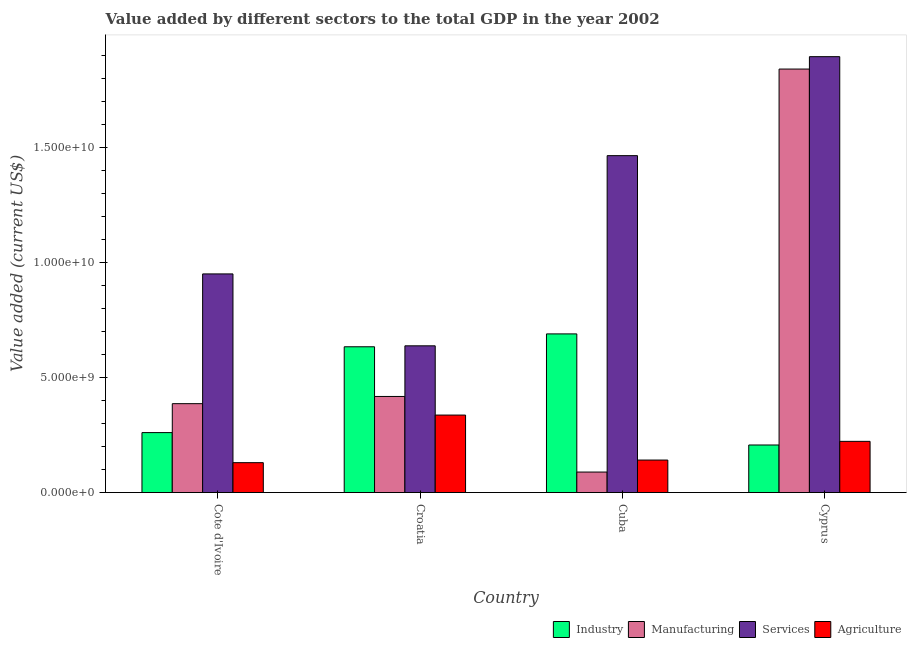Are the number of bars per tick equal to the number of legend labels?
Give a very brief answer. Yes. Are the number of bars on each tick of the X-axis equal?
Your answer should be very brief. Yes. How many bars are there on the 3rd tick from the left?
Ensure brevity in your answer.  4. What is the label of the 4th group of bars from the left?
Ensure brevity in your answer.  Cyprus. What is the value added by manufacturing sector in Cuba?
Your answer should be very brief. 8.92e+08. Across all countries, what is the maximum value added by industrial sector?
Your answer should be compact. 6.89e+09. Across all countries, what is the minimum value added by manufacturing sector?
Provide a short and direct response. 8.92e+08. In which country was the value added by agricultural sector maximum?
Your answer should be compact. Croatia. In which country was the value added by industrial sector minimum?
Make the answer very short. Cyprus. What is the total value added by agricultural sector in the graph?
Offer a very short reply. 8.31e+09. What is the difference between the value added by manufacturing sector in Cuba and that in Cyprus?
Provide a succinct answer. -1.75e+1. What is the difference between the value added by agricultural sector in Cuba and the value added by services sector in Cote d'Ivoire?
Make the answer very short. -8.08e+09. What is the average value added by agricultural sector per country?
Provide a succinct answer. 2.08e+09. What is the difference between the value added by manufacturing sector and value added by agricultural sector in Cote d'Ivoire?
Your answer should be very brief. 2.56e+09. What is the ratio of the value added by industrial sector in Croatia to that in Cyprus?
Your answer should be very brief. 3.06. Is the value added by manufacturing sector in Cuba less than that in Cyprus?
Provide a short and direct response. Yes. Is the difference between the value added by industrial sector in Cuba and Cyprus greater than the difference between the value added by services sector in Cuba and Cyprus?
Keep it short and to the point. Yes. What is the difference between the highest and the second highest value added by services sector?
Provide a succinct answer. 4.30e+09. What is the difference between the highest and the lowest value added by industrial sector?
Your answer should be compact. 4.83e+09. In how many countries, is the value added by services sector greater than the average value added by services sector taken over all countries?
Offer a very short reply. 2. Is it the case that in every country, the sum of the value added by industrial sector and value added by manufacturing sector is greater than the sum of value added by services sector and value added by agricultural sector?
Ensure brevity in your answer.  No. What does the 3rd bar from the left in Croatia represents?
Keep it short and to the point. Services. What does the 1st bar from the right in Cuba represents?
Your answer should be very brief. Agriculture. Is it the case that in every country, the sum of the value added by industrial sector and value added by manufacturing sector is greater than the value added by services sector?
Make the answer very short. No. Are all the bars in the graph horizontal?
Provide a succinct answer. No. What is the difference between two consecutive major ticks on the Y-axis?
Offer a very short reply. 5.00e+09. Does the graph contain grids?
Give a very brief answer. No. What is the title of the graph?
Your answer should be very brief. Value added by different sectors to the total GDP in the year 2002. What is the label or title of the Y-axis?
Your answer should be very brief. Value added (current US$). What is the Value added (current US$) of Industry in Cote d'Ivoire?
Offer a terse response. 2.61e+09. What is the Value added (current US$) in Manufacturing in Cote d'Ivoire?
Offer a terse response. 3.86e+09. What is the Value added (current US$) of Services in Cote d'Ivoire?
Keep it short and to the point. 9.50e+09. What is the Value added (current US$) in Agriculture in Cote d'Ivoire?
Make the answer very short. 1.30e+09. What is the Value added (current US$) in Industry in Croatia?
Keep it short and to the point. 6.33e+09. What is the Value added (current US$) of Manufacturing in Croatia?
Your response must be concise. 4.18e+09. What is the Value added (current US$) of Services in Croatia?
Keep it short and to the point. 6.37e+09. What is the Value added (current US$) of Agriculture in Croatia?
Offer a terse response. 3.37e+09. What is the Value added (current US$) of Industry in Cuba?
Make the answer very short. 6.89e+09. What is the Value added (current US$) in Manufacturing in Cuba?
Your response must be concise. 8.92e+08. What is the Value added (current US$) in Services in Cuba?
Your answer should be very brief. 1.46e+1. What is the Value added (current US$) of Agriculture in Cuba?
Provide a succinct answer. 1.41e+09. What is the Value added (current US$) of Industry in Cyprus?
Keep it short and to the point. 2.07e+09. What is the Value added (current US$) of Manufacturing in Cyprus?
Your answer should be very brief. 1.84e+1. What is the Value added (current US$) in Services in Cyprus?
Provide a succinct answer. 1.89e+1. What is the Value added (current US$) of Agriculture in Cyprus?
Offer a very short reply. 2.23e+09. Across all countries, what is the maximum Value added (current US$) of Industry?
Offer a very short reply. 6.89e+09. Across all countries, what is the maximum Value added (current US$) of Manufacturing?
Your answer should be very brief. 1.84e+1. Across all countries, what is the maximum Value added (current US$) of Services?
Make the answer very short. 1.89e+1. Across all countries, what is the maximum Value added (current US$) in Agriculture?
Give a very brief answer. 3.37e+09. Across all countries, what is the minimum Value added (current US$) of Industry?
Offer a terse response. 2.07e+09. Across all countries, what is the minimum Value added (current US$) in Manufacturing?
Make the answer very short. 8.92e+08. Across all countries, what is the minimum Value added (current US$) of Services?
Your answer should be compact. 6.37e+09. Across all countries, what is the minimum Value added (current US$) in Agriculture?
Provide a short and direct response. 1.30e+09. What is the total Value added (current US$) in Industry in the graph?
Your answer should be very brief. 1.79e+1. What is the total Value added (current US$) in Manufacturing in the graph?
Keep it short and to the point. 2.73e+1. What is the total Value added (current US$) of Services in the graph?
Offer a very short reply. 4.94e+1. What is the total Value added (current US$) of Agriculture in the graph?
Offer a very short reply. 8.31e+09. What is the difference between the Value added (current US$) of Industry in Cote d'Ivoire and that in Croatia?
Provide a succinct answer. -3.73e+09. What is the difference between the Value added (current US$) of Manufacturing in Cote d'Ivoire and that in Croatia?
Your response must be concise. -3.13e+08. What is the difference between the Value added (current US$) in Services in Cote d'Ivoire and that in Croatia?
Keep it short and to the point. 3.12e+09. What is the difference between the Value added (current US$) in Agriculture in Cote d'Ivoire and that in Croatia?
Provide a short and direct response. -2.07e+09. What is the difference between the Value added (current US$) of Industry in Cote d'Ivoire and that in Cuba?
Ensure brevity in your answer.  -4.29e+09. What is the difference between the Value added (current US$) in Manufacturing in Cote d'Ivoire and that in Cuba?
Your answer should be compact. 2.97e+09. What is the difference between the Value added (current US$) of Services in Cote d'Ivoire and that in Cuba?
Offer a very short reply. -5.14e+09. What is the difference between the Value added (current US$) in Agriculture in Cote d'Ivoire and that in Cuba?
Keep it short and to the point. -1.13e+08. What is the difference between the Value added (current US$) in Industry in Cote d'Ivoire and that in Cyprus?
Keep it short and to the point. 5.39e+08. What is the difference between the Value added (current US$) of Manufacturing in Cote d'Ivoire and that in Cyprus?
Provide a short and direct response. -1.45e+1. What is the difference between the Value added (current US$) of Services in Cote d'Ivoire and that in Cyprus?
Offer a terse response. -9.44e+09. What is the difference between the Value added (current US$) of Agriculture in Cote d'Ivoire and that in Cyprus?
Offer a very short reply. -9.26e+08. What is the difference between the Value added (current US$) in Industry in Croatia and that in Cuba?
Provide a short and direct response. -5.59e+08. What is the difference between the Value added (current US$) of Manufacturing in Croatia and that in Cuba?
Offer a terse response. 3.28e+09. What is the difference between the Value added (current US$) of Services in Croatia and that in Cuba?
Give a very brief answer. -8.26e+09. What is the difference between the Value added (current US$) of Agriculture in Croatia and that in Cuba?
Ensure brevity in your answer.  1.95e+09. What is the difference between the Value added (current US$) in Industry in Croatia and that in Cyprus?
Give a very brief answer. 4.27e+09. What is the difference between the Value added (current US$) in Manufacturing in Croatia and that in Cyprus?
Provide a succinct answer. -1.42e+1. What is the difference between the Value added (current US$) in Services in Croatia and that in Cyprus?
Provide a succinct answer. -1.26e+1. What is the difference between the Value added (current US$) in Agriculture in Croatia and that in Cyprus?
Your answer should be compact. 1.14e+09. What is the difference between the Value added (current US$) in Industry in Cuba and that in Cyprus?
Your answer should be compact. 4.83e+09. What is the difference between the Value added (current US$) of Manufacturing in Cuba and that in Cyprus?
Your answer should be compact. -1.75e+1. What is the difference between the Value added (current US$) in Services in Cuba and that in Cyprus?
Keep it short and to the point. -4.30e+09. What is the difference between the Value added (current US$) of Agriculture in Cuba and that in Cyprus?
Offer a terse response. -8.13e+08. What is the difference between the Value added (current US$) of Industry in Cote d'Ivoire and the Value added (current US$) of Manufacturing in Croatia?
Make the answer very short. -1.57e+09. What is the difference between the Value added (current US$) of Industry in Cote d'Ivoire and the Value added (current US$) of Services in Croatia?
Offer a very short reply. -3.77e+09. What is the difference between the Value added (current US$) in Industry in Cote d'Ivoire and the Value added (current US$) in Agriculture in Croatia?
Ensure brevity in your answer.  -7.61e+08. What is the difference between the Value added (current US$) in Manufacturing in Cote d'Ivoire and the Value added (current US$) in Services in Croatia?
Offer a terse response. -2.51e+09. What is the difference between the Value added (current US$) of Manufacturing in Cote d'Ivoire and the Value added (current US$) of Agriculture in Croatia?
Keep it short and to the point. 4.95e+08. What is the difference between the Value added (current US$) in Services in Cote d'Ivoire and the Value added (current US$) in Agriculture in Croatia?
Keep it short and to the point. 6.13e+09. What is the difference between the Value added (current US$) of Industry in Cote d'Ivoire and the Value added (current US$) of Manufacturing in Cuba?
Provide a succinct answer. 1.71e+09. What is the difference between the Value added (current US$) of Industry in Cote d'Ivoire and the Value added (current US$) of Services in Cuba?
Your answer should be very brief. -1.20e+1. What is the difference between the Value added (current US$) of Industry in Cote d'Ivoire and the Value added (current US$) of Agriculture in Cuba?
Your response must be concise. 1.19e+09. What is the difference between the Value added (current US$) of Manufacturing in Cote d'Ivoire and the Value added (current US$) of Services in Cuba?
Keep it short and to the point. -1.08e+1. What is the difference between the Value added (current US$) in Manufacturing in Cote d'Ivoire and the Value added (current US$) in Agriculture in Cuba?
Offer a terse response. 2.45e+09. What is the difference between the Value added (current US$) in Services in Cote d'Ivoire and the Value added (current US$) in Agriculture in Cuba?
Keep it short and to the point. 8.08e+09. What is the difference between the Value added (current US$) of Industry in Cote d'Ivoire and the Value added (current US$) of Manufacturing in Cyprus?
Your answer should be very brief. -1.58e+1. What is the difference between the Value added (current US$) in Industry in Cote d'Ivoire and the Value added (current US$) in Services in Cyprus?
Your answer should be very brief. -1.63e+1. What is the difference between the Value added (current US$) of Industry in Cote d'Ivoire and the Value added (current US$) of Agriculture in Cyprus?
Provide a short and direct response. 3.80e+08. What is the difference between the Value added (current US$) of Manufacturing in Cote d'Ivoire and the Value added (current US$) of Services in Cyprus?
Offer a very short reply. -1.51e+1. What is the difference between the Value added (current US$) in Manufacturing in Cote d'Ivoire and the Value added (current US$) in Agriculture in Cyprus?
Your answer should be compact. 1.64e+09. What is the difference between the Value added (current US$) in Services in Cote d'Ivoire and the Value added (current US$) in Agriculture in Cyprus?
Make the answer very short. 7.27e+09. What is the difference between the Value added (current US$) of Industry in Croatia and the Value added (current US$) of Manufacturing in Cuba?
Give a very brief answer. 5.44e+09. What is the difference between the Value added (current US$) in Industry in Croatia and the Value added (current US$) in Services in Cuba?
Offer a very short reply. -8.30e+09. What is the difference between the Value added (current US$) in Industry in Croatia and the Value added (current US$) in Agriculture in Cuba?
Your answer should be very brief. 4.92e+09. What is the difference between the Value added (current US$) in Manufacturing in Croatia and the Value added (current US$) in Services in Cuba?
Provide a short and direct response. -1.05e+1. What is the difference between the Value added (current US$) of Manufacturing in Croatia and the Value added (current US$) of Agriculture in Cuba?
Provide a short and direct response. 2.76e+09. What is the difference between the Value added (current US$) in Services in Croatia and the Value added (current US$) in Agriculture in Cuba?
Keep it short and to the point. 4.96e+09. What is the difference between the Value added (current US$) in Industry in Croatia and the Value added (current US$) in Manufacturing in Cyprus?
Your answer should be compact. -1.21e+1. What is the difference between the Value added (current US$) of Industry in Croatia and the Value added (current US$) of Services in Cyprus?
Keep it short and to the point. -1.26e+1. What is the difference between the Value added (current US$) of Industry in Croatia and the Value added (current US$) of Agriculture in Cyprus?
Provide a short and direct response. 4.11e+09. What is the difference between the Value added (current US$) in Manufacturing in Croatia and the Value added (current US$) in Services in Cyprus?
Give a very brief answer. -1.48e+1. What is the difference between the Value added (current US$) of Manufacturing in Croatia and the Value added (current US$) of Agriculture in Cyprus?
Give a very brief answer. 1.95e+09. What is the difference between the Value added (current US$) in Services in Croatia and the Value added (current US$) in Agriculture in Cyprus?
Provide a succinct answer. 4.15e+09. What is the difference between the Value added (current US$) in Industry in Cuba and the Value added (current US$) in Manufacturing in Cyprus?
Provide a succinct answer. -1.15e+1. What is the difference between the Value added (current US$) of Industry in Cuba and the Value added (current US$) of Services in Cyprus?
Provide a short and direct response. -1.20e+1. What is the difference between the Value added (current US$) of Industry in Cuba and the Value added (current US$) of Agriculture in Cyprus?
Make the answer very short. 4.67e+09. What is the difference between the Value added (current US$) of Manufacturing in Cuba and the Value added (current US$) of Services in Cyprus?
Provide a succinct answer. -1.80e+1. What is the difference between the Value added (current US$) in Manufacturing in Cuba and the Value added (current US$) in Agriculture in Cyprus?
Your response must be concise. -1.33e+09. What is the difference between the Value added (current US$) in Services in Cuba and the Value added (current US$) in Agriculture in Cyprus?
Give a very brief answer. 1.24e+1. What is the average Value added (current US$) of Industry per country?
Your answer should be very brief. 4.47e+09. What is the average Value added (current US$) of Manufacturing per country?
Your answer should be compact. 6.83e+09. What is the average Value added (current US$) of Services per country?
Provide a short and direct response. 1.24e+1. What is the average Value added (current US$) in Agriculture per country?
Offer a very short reply. 2.08e+09. What is the difference between the Value added (current US$) in Industry and Value added (current US$) in Manufacturing in Cote d'Ivoire?
Keep it short and to the point. -1.26e+09. What is the difference between the Value added (current US$) in Industry and Value added (current US$) in Services in Cote d'Ivoire?
Keep it short and to the point. -6.89e+09. What is the difference between the Value added (current US$) of Industry and Value added (current US$) of Agriculture in Cote d'Ivoire?
Offer a very short reply. 1.31e+09. What is the difference between the Value added (current US$) in Manufacturing and Value added (current US$) in Services in Cote d'Ivoire?
Offer a terse response. -5.64e+09. What is the difference between the Value added (current US$) in Manufacturing and Value added (current US$) in Agriculture in Cote d'Ivoire?
Ensure brevity in your answer.  2.56e+09. What is the difference between the Value added (current US$) in Services and Value added (current US$) in Agriculture in Cote d'Ivoire?
Your response must be concise. 8.20e+09. What is the difference between the Value added (current US$) of Industry and Value added (current US$) of Manufacturing in Croatia?
Your answer should be very brief. 2.16e+09. What is the difference between the Value added (current US$) of Industry and Value added (current US$) of Services in Croatia?
Make the answer very short. -4.13e+07. What is the difference between the Value added (current US$) of Industry and Value added (current US$) of Agriculture in Croatia?
Give a very brief answer. 2.97e+09. What is the difference between the Value added (current US$) in Manufacturing and Value added (current US$) in Services in Croatia?
Provide a succinct answer. -2.20e+09. What is the difference between the Value added (current US$) in Manufacturing and Value added (current US$) in Agriculture in Croatia?
Give a very brief answer. 8.08e+08. What is the difference between the Value added (current US$) of Services and Value added (current US$) of Agriculture in Croatia?
Provide a succinct answer. 3.01e+09. What is the difference between the Value added (current US$) in Industry and Value added (current US$) in Manufacturing in Cuba?
Ensure brevity in your answer.  6.00e+09. What is the difference between the Value added (current US$) in Industry and Value added (current US$) in Services in Cuba?
Your answer should be very brief. -7.74e+09. What is the difference between the Value added (current US$) in Industry and Value added (current US$) in Agriculture in Cuba?
Provide a succinct answer. 5.48e+09. What is the difference between the Value added (current US$) in Manufacturing and Value added (current US$) in Services in Cuba?
Offer a terse response. -1.37e+1. What is the difference between the Value added (current US$) in Manufacturing and Value added (current US$) in Agriculture in Cuba?
Keep it short and to the point. -5.21e+08. What is the difference between the Value added (current US$) in Services and Value added (current US$) in Agriculture in Cuba?
Ensure brevity in your answer.  1.32e+1. What is the difference between the Value added (current US$) of Industry and Value added (current US$) of Manufacturing in Cyprus?
Your response must be concise. -1.63e+1. What is the difference between the Value added (current US$) in Industry and Value added (current US$) in Services in Cyprus?
Keep it short and to the point. -1.69e+1. What is the difference between the Value added (current US$) of Industry and Value added (current US$) of Agriculture in Cyprus?
Your answer should be compact. -1.58e+08. What is the difference between the Value added (current US$) in Manufacturing and Value added (current US$) in Services in Cyprus?
Provide a succinct answer. -5.38e+08. What is the difference between the Value added (current US$) of Manufacturing and Value added (current US$) of Agriculture in Cyprus?
Your answer should be compact. 1.62e+1. What is the difference between the Value added (current US$) of Services and Value added (current US$) of Agriculture in Cyprus?
Your response must be concise. 1.67e+1. What is the ratio of the Value added (current US$) in Industry in Cote d'Ivoire to that in Croatia?
Ensure brevity in your answer.  0.41. What is the ratio of the Value added (current US$) of Manufacturing in Cote d'Ivoire to that in Croatia?
Keep it short and to the point. 0.93. What is the ratio of the Value added (current US$) of Services in Cote d'Ivoire to that in Croatia?
Ensure brevity in your answer.  1.49. What is the ratio of the Value added (current US$) of Agriculture in Cote d'Ivoire to that in Croatia?
Your answer should be very brief. 0.39. What is the ratio of the Value added (current US$) of Industry in Cote d'Ivoire to that in Cuba?
Offer a terse response. 0.38. What is the ratio of the Value added (current US$) of Manufacturing in Cote d'Ivoire to that in Cuba?
Your answer should be compact. 4.33. What is the ratio of the Value added (current US$) in Services in Cote d'Ivoire to that in Cuba?
Provide a succinct answer. 0.65. What is the ratio of the Value added (current US$) of Agriculture in Cote d'Ivoire to that in Cuba?
Ensure brevity in your answer.  0.92. What is the ratio of the Value added (current US$) of Industry in Cote d'Ivoire to that in Cyprus?
Offer a very short reply. 1.26. What is the ratio of the Value added (current US$) of Manufacturing in Cote d'Ivoire to that in Cyprus?
Provide a short and direct response. 0.21. What is the ratio of the Value added (current US$) in Services in Cote d'Ivoire to that in Cyprus?
Give a very brief answer. 0.5. What is the ratio of the Value added (current US$) in Agriculture in Cote d'Ivoire to that in Cyprus?
Your response must be concise. 0.58. What is the ratio of the Value added (current US$) of Industry in Croatia to that in Cuba?
Ensure brevity in your answer.  0.92. What is the ratio of the Value added (current US$) in Manufacturing in Croatia to that in Cuba?
Your response must be concise. 4.68. What is the ratio of the Value added (current US$) of Services in Croatia to that in Cuba?
Provide a short and direct response. 0.44. What is the ratio of the Value added (current US$) in Agriculture in Croatia to that in Cuba?
Ensure brevity in your answer.  2.38. What is the ratio of the Value added (current US$) of Industry in Croatia to that in Cyprus?
Provide a short and direct response. 3.06. What is the ratio of the Value added (current US$) in Manufacturing in Croatia to that in Cyprus?
Offer a very short reply. 0.23. What is the ratio of the Value added (current US$) of Services in Croatia to that in Cyprus?
Provide a succinct answer. 0.34. What is the ratio of the Value added (current US$) in Agriculture in Croatia to that in Cyprus?
Your answer should be very brief. 1.51. What is the ratio of the Value added (current US$) of Industry in Cuba to that in Cyprus?
Provide a short and direct response. 3.33. What is the ratio of the Value added (current US$) in Manufacturing in Cuba to that in Cyprus?
Provide a succinct answer. 0.05. What is the ratio of the Value added (current US$) in Services in Cuba to that in Cyprus?
Give a very brief answer. 0.77. What is the ratio of the Value added (current US$) of Agriculture in Cuba to that in Cyprus?
Ensure brevity in your answer.  0.63. What is the difference between the highest and the second highest Value added (current US$) of Industry?
Ensure brevity in your answer.  5.59e+08. What is the difference between the highest and the second highest Value added (current US$) in Manufacturing?
Offer a very short reply. 1.42e+1. What is the difference between the highest and the second highest Value added (current US$) of Services?
Your response must be concise. 4.30e+09. What is the difference between the highest and the second highest Value added (current US$) in Agriculture?
Keep it short and to the point. 1.14e+09. What is the difference between the highest and the lowest Value added (current US$) of Industry?
Your response must be concise. 4.83e+09. What is the difference between the highest and the lowest Value added (current US$) in Manufacturing?
Your answer should be compact. 1.75e+1. What is the difference between the highest and the lowest Value added (current US$) in Services?
Offer a terse response. 1.26e+1. What is the difference between the highest and the lowest Value added (current US$) of Agriculture?
Keep it short and to the point. 2.07e+09. 